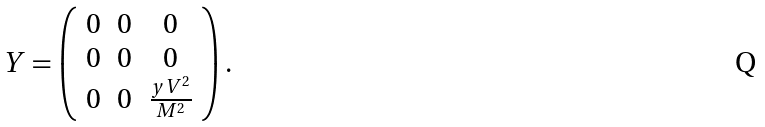Convert formula to latex. <formula><loc_0><loc_0><loc_500><loc_500>Y = \left ( \begin{array} { c c c } 0 & 0 & 0 \\ 0 & 0 & 0 \\ 0 & 0 & \frac { y V ^ { 2 } } { M ^ { 2 } } \end{array} \right ) .</formula> 